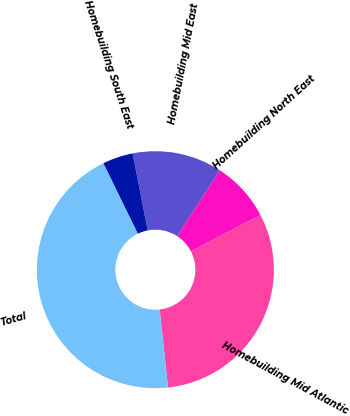Convert chart. <chart><loc_0><loc_0><loc_500><loc_500><pie_chart><fcel>Homebuilding Mid Atlantic<fcel>Homebuilding North East<fcel>Homebuilding Mid East<fcel>Homebuilding South East<fcel>Total<nl><fcel>30.94%<fcel>8.2%<fcel>12.23%<fcel>4.17%<fcel>44.46%<nl></chart> 